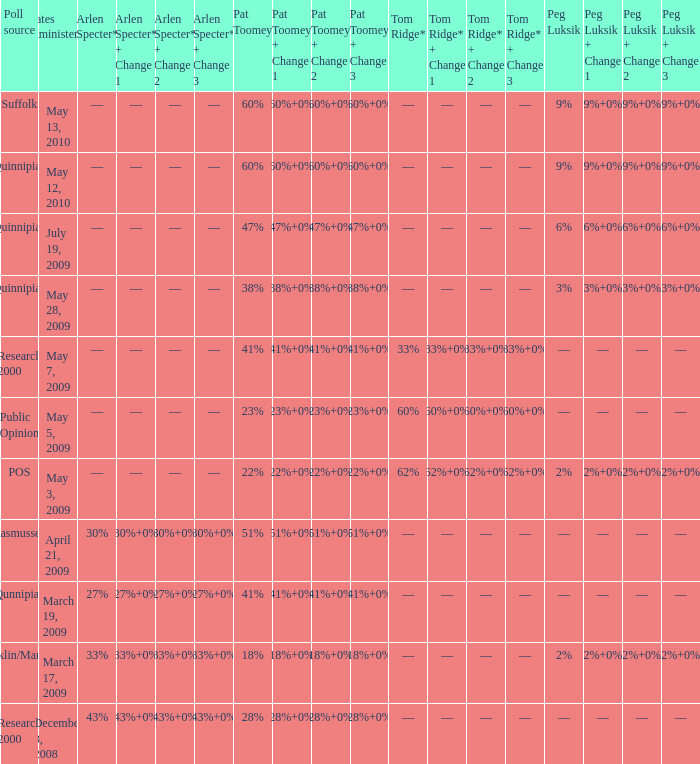Which Dates administered has an Arlen Specter* of ––, and a Peg Luksik of 9%? May 13, 2010, May 12, 2010. 